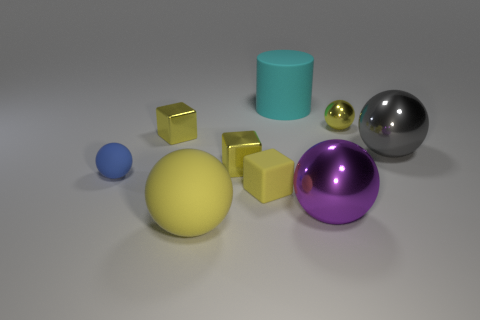Is there a small matte cube of the same color as the tiny metal ball?
Keep it short and to the point. Yes. What is the shape of the small yellow thing that is in front of the tiny blue ball?
Offer a terse response. Cube. Does the blue thing have the same material as the large gray sphere that is behind the tiny blue object?
Offer a very short reply. No. Is the shape of the large yellow rubber thing the same as the blue rubber object?
Keep it short and to the point. Yes. What material is the small yellow thing that is the same shape as the gray object?
Ensure brevity in your answer.  Metal. The object that is behind the gray thing and to the left of the yellow rubber sphere is what color?
Offer a very short reply. Yellow. The small matte cube has what color?
Offer a very short reply. Yellow. What is the material of the other sphere that is the same color as the tiny shiny sphere?
Make the answer very short. Rubber. Are there any tiny metal objects that have the same shape as the blue matte thing?
Provide a succinct answer. Yes. What is the size of the yellow rubber cube that is behind the purple metallic sphere?
Ensure brevity in your answer.  Small. 